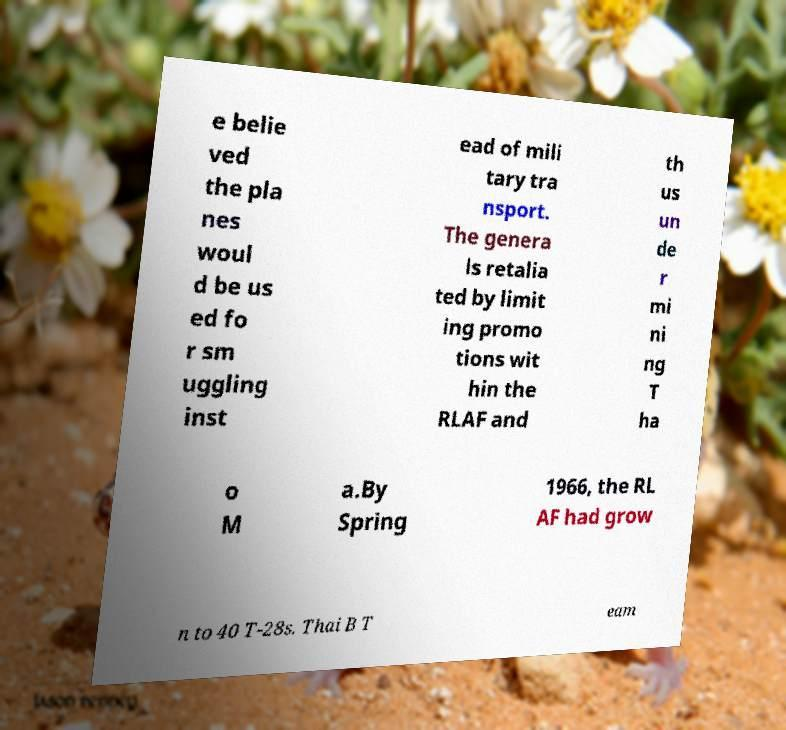Can you read and provide the text displayed in the image?This photo seems to have some interesting text. Can you extract and type it out for me? e belie ved the pla nes woul d be us ed fo r sm uggling inst ead of mili tary tra nsport. The genera ls retalia ted by limit ing promo tions wit hin the RLAF and th us un de r mi ni ng T ha o M a.By Spring 1966, the RL AF had grow n to 40 T-28s. Thai B T eam 